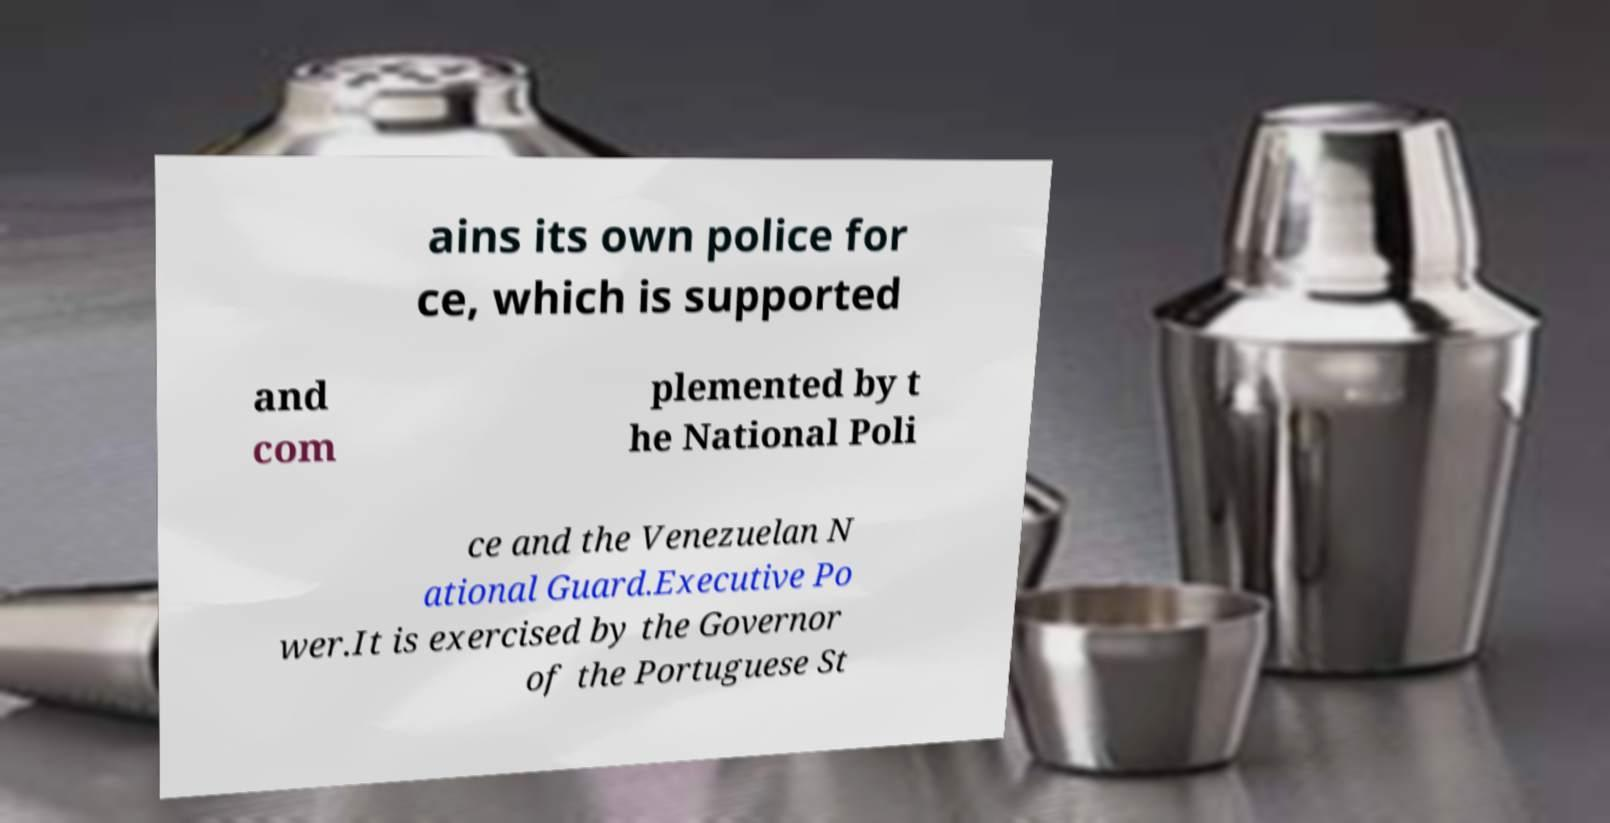Can you read and provide the text displayed in the image?This photo seems to have some interesting text. Can you extract and type it out for me? ains its own police for ce, which is supported and com plemented by t he National Poli ce and the Venezuelan N ational Guard.Executive Po wer.It is exercised by the Governor of the Portuguese St 